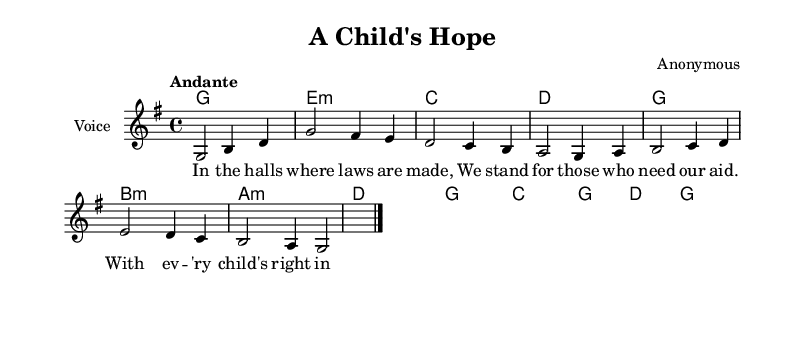What is the key signature of this music? The key signature is G major, which has one sharp (F#). This is indicated at the beginning of the staff with the sharp sign.
Answer: G major What is the time signature of this piece? The time signature is 4/4, which means there are four beats in each measure and a quarter note gets one beat. This can be identified at the beginning of the score.
Answer: 4/4 What is the tempo marking for this piece? The tempo marking is "Andante," which indicates a moderately slow tempo. This direction is placed at the start of the score, right under the time signature.
Answer: Andante How many measures are present in the melody? The melody consists of eight measures, each separated by a vertical line called a bar line. By counting each section between the bar lines, we arrive at the total.
Answer: 8 What is the first lyric line of the piece? The first lyric line is "In the halls where laws are made." This can be found directly beneath the melody notes.
Answer: In the halls where laws are made What is the chord progression of the first four measures? The chord progression for the first four measures is G, E minor, C, and D. This can be identified by looking at the chord names written above the melody notes.
Answer: G, E minor, C, D How does the song relate to child welfare reform? It underscores the importance of legislative advocacy for children's rights, as highlighted in the lyrics that discuss standing for those who need aid and designing a brighter future for children. This thematic content emphasizes the connection to child welfare reform and advocacy.
Answer: Advocacy for children's rights 